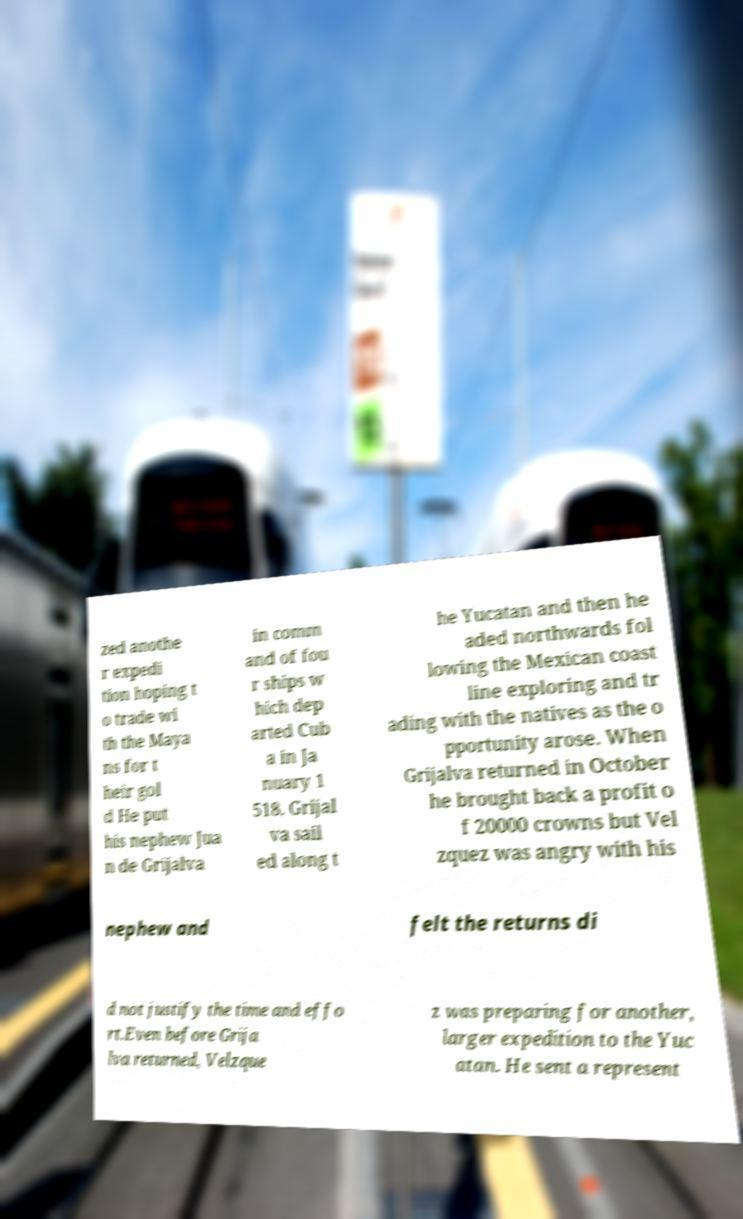I need the written content from this picture converted into text. Can you do that? zed anothe r expedi tion hoping t o trade wi th the Maya ns for t heir gol d He put his nephew Jua n de Grijalva in comm and of fou r ships w hich dep arted Cub a in Ja nuary 1 518. Grijal va sail ed along t he Yucatan and then he aded northwards fol lowing the Mexican coast line exploring and tr ading with the natives as the o pportunity arose. When Grijalva returned in October he brought back a profit o f 20000 crowns but Vel zquez was angry with his nephew and felt the returns di d not justify the time and effo rt.Even before Grija lva returned, Velzque z was preparing for another, larger expedition to the Yuc atan. He sent a represent 